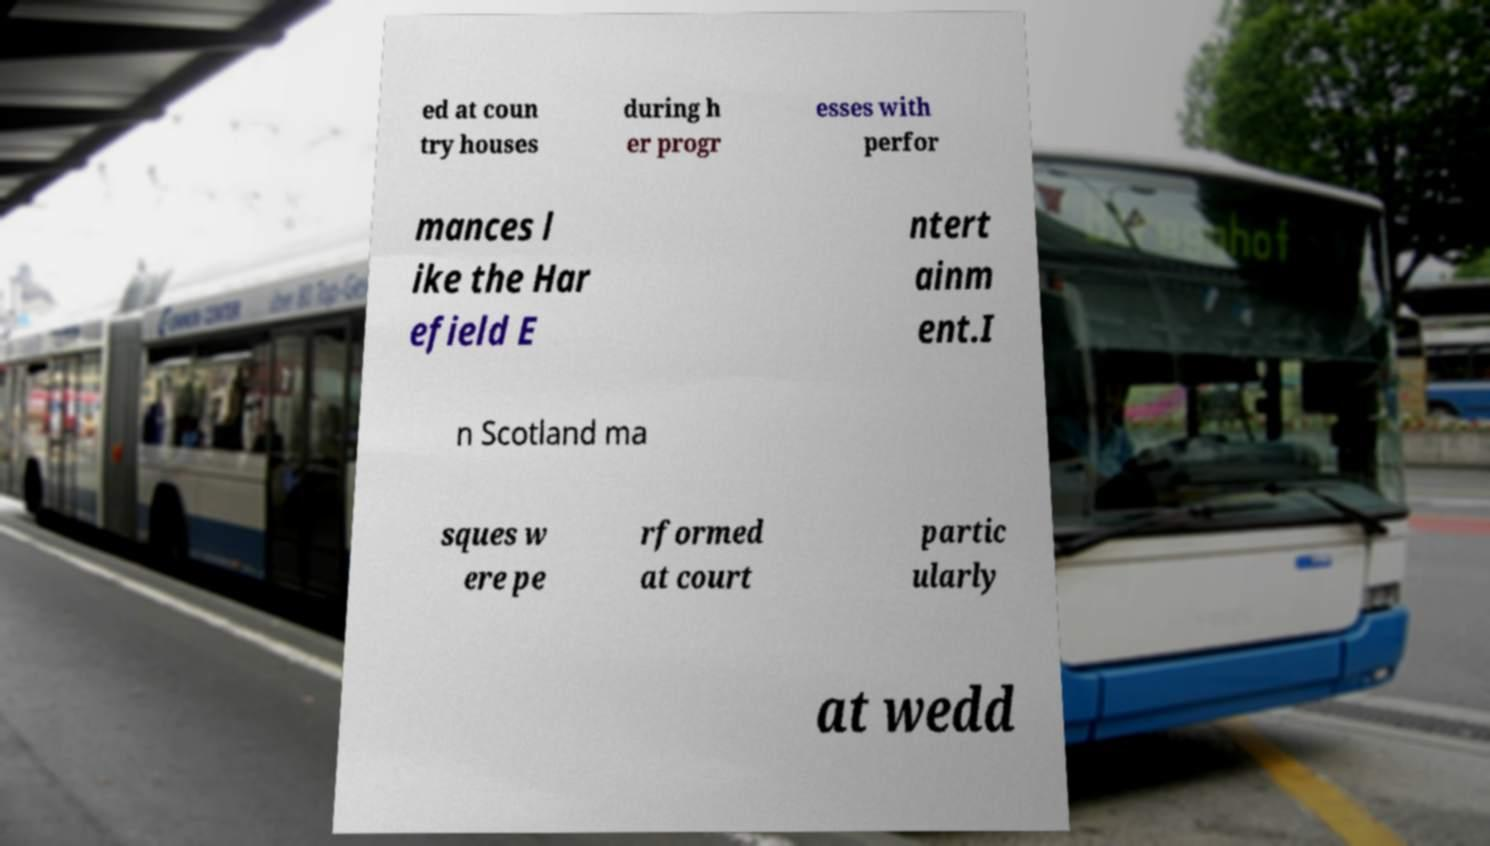Can you accurately transcribe the text from the provided image for me? ed at coun try houses during h er progr esses with perfor mances l ike the Har efield E ntert ainm ent.I n Scotland ma sques w ere pe rformed at court partic ularly at wedd 